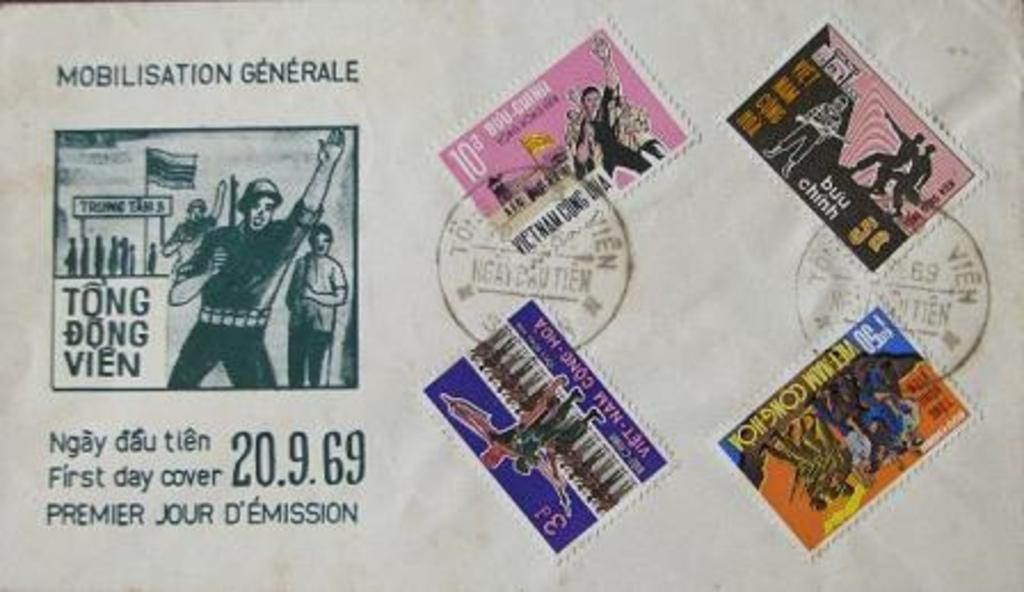What is present on the paper in the image? The paper has stamps and text on it. What can be seen on the stamps on the paper? The stamps on the paper are not visible in the image, but their presence is mentioned. What type of information is present on the paper? The paper has text on it, which suggests it contains some form of written information. What type of substance is increasing in the image? There is no substance present in the image, nor is there any indication of an increase in anything. 